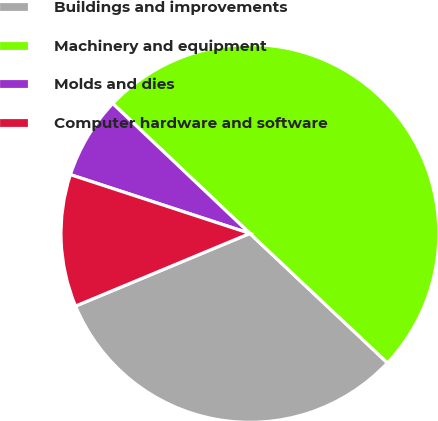Convert chart to OTSL. <chart><loc_0><loc_0><loc_500><loc_500><pie_chart><fcel>Buildings and improvements<fcel>Machinery and equipment<fcel>Molds and dies<fcel>Computer hardware and software<nl><fcel>31.7%<fcel>49.95%<fcel>7.03%<fcel>11.32%<nl></chart> 